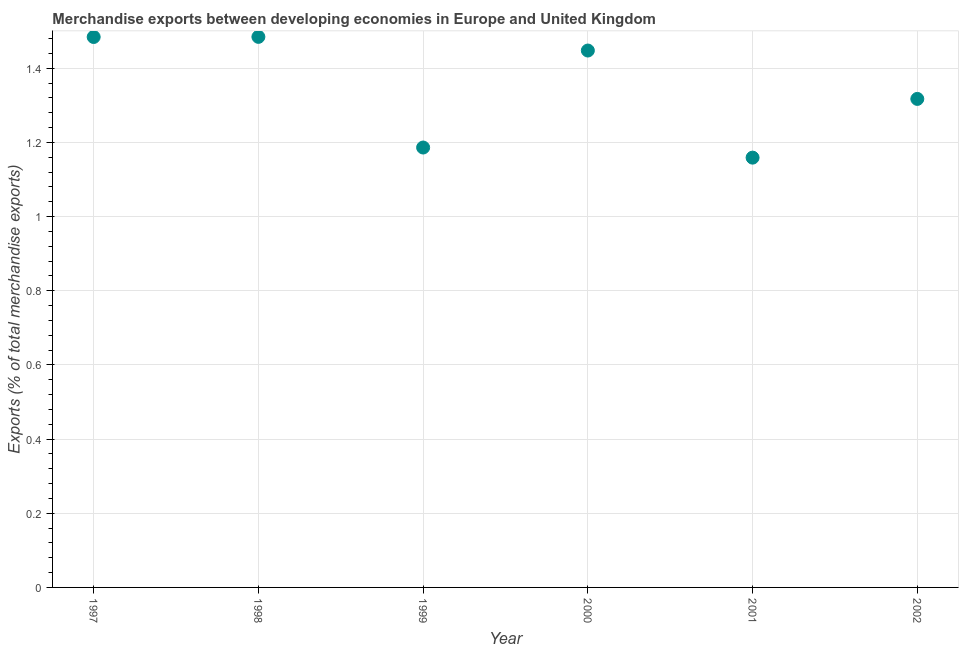What is the merchandise exports in 1999?
Provide a short and direct response. 1.19. Across all years, what is the maximum merchandise exports?
Keep it short and to the point. 1.48. Across all years, what is the minimum merchandise exports?
Offer a very short reply. 1.16. In which year was the merchandise exports minimum?
Ensure brevity in your answer.  2001. What is the sum of the merchandise exports?
Your answer should be very brief. 8.08. What is the difference between the merchandise exports in 1999 and 2000?
Offer a terse response. -0.26. What is the average merchandise exports per year?
Make the answer very short. 1.35. What is the median merchandise exports?
Offer a terse response. 1.38. Do a majority of the years between 2000 and 1998 (inclusive) have merchandise exports greater than 1.4000000000000001 %?
Offer a very short reply. No. What is the ratio of the merchandise exports in 1998 to that in 2001?
Keep it short and to the point. 1.28. Is the merchandise exports in 1999 less than that in 2002?
Offer a terse response. Yes. Is the difference between the merchandise exports in 2001 and 2002 greater than the difference between any two years?
Give a very brief answer. No. What is the difference between the highest and the second highest merchandise exports?
Make the answer very short. 0. What is the difference between the highest and the lowest merchandise exports?
Your answer should be compact. 0.33. In how many years, is the merchandise exports greater than the average merchandise exports taken over all years?
Make the answer very short. 3. How many dotlines are there?
Your response must be concise. 1. Are the values on the major ticks of Y-axis written in scientific E-notation?
Provide a short and direct response. No. What is the title of the graph?
Your answer should be compact. Merchandise exports between developing economies in Europe and United Kingdom. What is the label or title of the X-axis?
Your answer should be very brief. Year. What is the label or title of the Y-axis?
Provide a short and direct response. Exports (% of total merchandise exports). What is the Exports (% of total merchandise exports) in 1997?
Ensure brevity in your answer.  1.48. What is the Exports (% of total merchandise exports) in 1998?
Provide a short and direct response. 1.48. What is the Exports (% of total merchandise exports) in 1999?
Provide a short and direct response. 1.19. What is the Exports (% of total merchandise exports) in 2000?
Offer a very short reply. 1.45. What is the Exports (% of total merchandise exports) in 2001?
Your answer should be very brief. 1.16. What is the Exports (% of total merchandise exports) in 2002?
Ensure brevity in your answer.  1.32. What is the difference between the Exports (% of total merchandise exports) in 1997 and 1998?
Provide a short and direct response. -0. What is the difference between the Exports (% of total merchandise exports) in 1997 and 1999?
Offer a terse response. 0.3. What is the difference between the Exports (% of total merchandise exports) in 1997 and 2000?
Your answer should be very brief. 0.04. What is the difference between the Exports (% of total merchandise exports) in 1997 and 2001?
Ensure brevity in your answer.  0.33. What is the difference between the Exports (% of total merchandise exports) in 1997 and 2002?
Your answer should be compact. 0.17. What is the difference between the Exports (% of total merchandise exports) in 1998 and 1999?
Provide a short and direct response. 0.3. What is the difference between the Exports (% of total merchandise exports) in 1998 and 2000?
Ensure brevity in your answer.  0.04. What is the difference between the Exports (% of total merchandise exports) in 1998 and 2001?
Offer a very short reply. 0.33. What is the difference between the Exports (% of total merchandise exports) in 1998 and 2002?
Make the answer very short. 0.17. What is the difference between the Exports (% of total merchandise exports) in 1999 and 2000?
Your answer should be compact. -0.26. What is the difference between the Exports (% of total merchandise exports) in 1999 and 2001?
Ensure brevity in your answer.  0.03. What is the difference between the Exports (% of total merchandise exports) in 1999 and 2002?
Your answer should be compact. -0.13. What is the difference between the Exports (% of total merchandise exports) in 2000 and 2001?
Provide a short and direct response. 0.29. What is the difference between the Exports (% of total merchandise exports) in 2000 and 2002?
Your response must be concise. 0.13. What is the difference between the Exports (% of total merchandise exports) in 2001 and 2002?
Offer a terse response. -0.16. What is the ratio of the Exports (% of total merchandise exports) in 1997 to that in 1998?
Keep it short and to the point. 1. What is the ratio of the Exports (% of total merchandise exports) in 1997 to that in 1999?
Your answer should be compact. 1.25. What is the ratio of the Exports (% of total merchandise exports) in 1997 to that in 2000?
Provide a short and direct response. 1.02. What is the ratio of the Exports (% of total merchandise exports) in 1997 to that in 2001?
Your answer should be very brief. 1.28. What is the ratio of the Exports (% of total merchandise exports) in 1997 to that in 2002?
Make the answer very short. 1.13. What is the ratio of the Exports (% of total merchandise exports) in 1998 to that in 1999?
Keep it short and to the point. 1.25. What is the ratio of the Exports (% of total merchandise exports) in 1998 to that in 2001?
Provide a succinct answer. 1.28. What is the ratio of the Exports (% of total merchandise exports) in 1998 to that in 2002?
Offer a terse response. 1.13. What is the ratio of the Exports (% of total merchandise exports) in 1999 to that in 2000?
Your answer should be compact. 0.82. What is the ratio of the Exports (% of total merchandise exports) in 1999 to that in 2001?
Give a very brief answer. 1.02. What is the ratio of the Exports (% of total merchandise exports) in 1999 to that in 2002?
Offer a very short reply. 0.9. What is the ratio of the Exports (% of total merchandise exports) in 2000 to that in 2001?
Give a very brief answer. 1.25. What is the ratio of the Exports (% of total merchandise exports) in 2000 to that in 2002?
Provide a short and direct response. 1.1. 